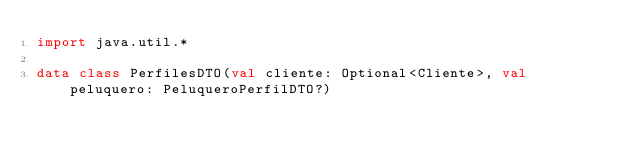<code> <loc_0><loc_0><loc_500><loc_500><_Kotlin_>import java.util.*

data class PerfilesDTO(val cliente: Optional<Cliente>, val peluquero: PeluqueroPerfilDTO?)
</code> 